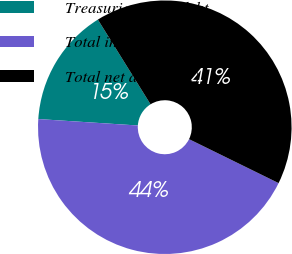Convert chart. <chart><loc_0><loc_0><loc_500><loc_500><pie_chart><fcel>Treasuries other debt<fcel>Total investments at fair<fcel>Total net assets ^(2)<nl><fcel>15.12%<fcel>43.77%<fcel>41.12%<nl></chart> 